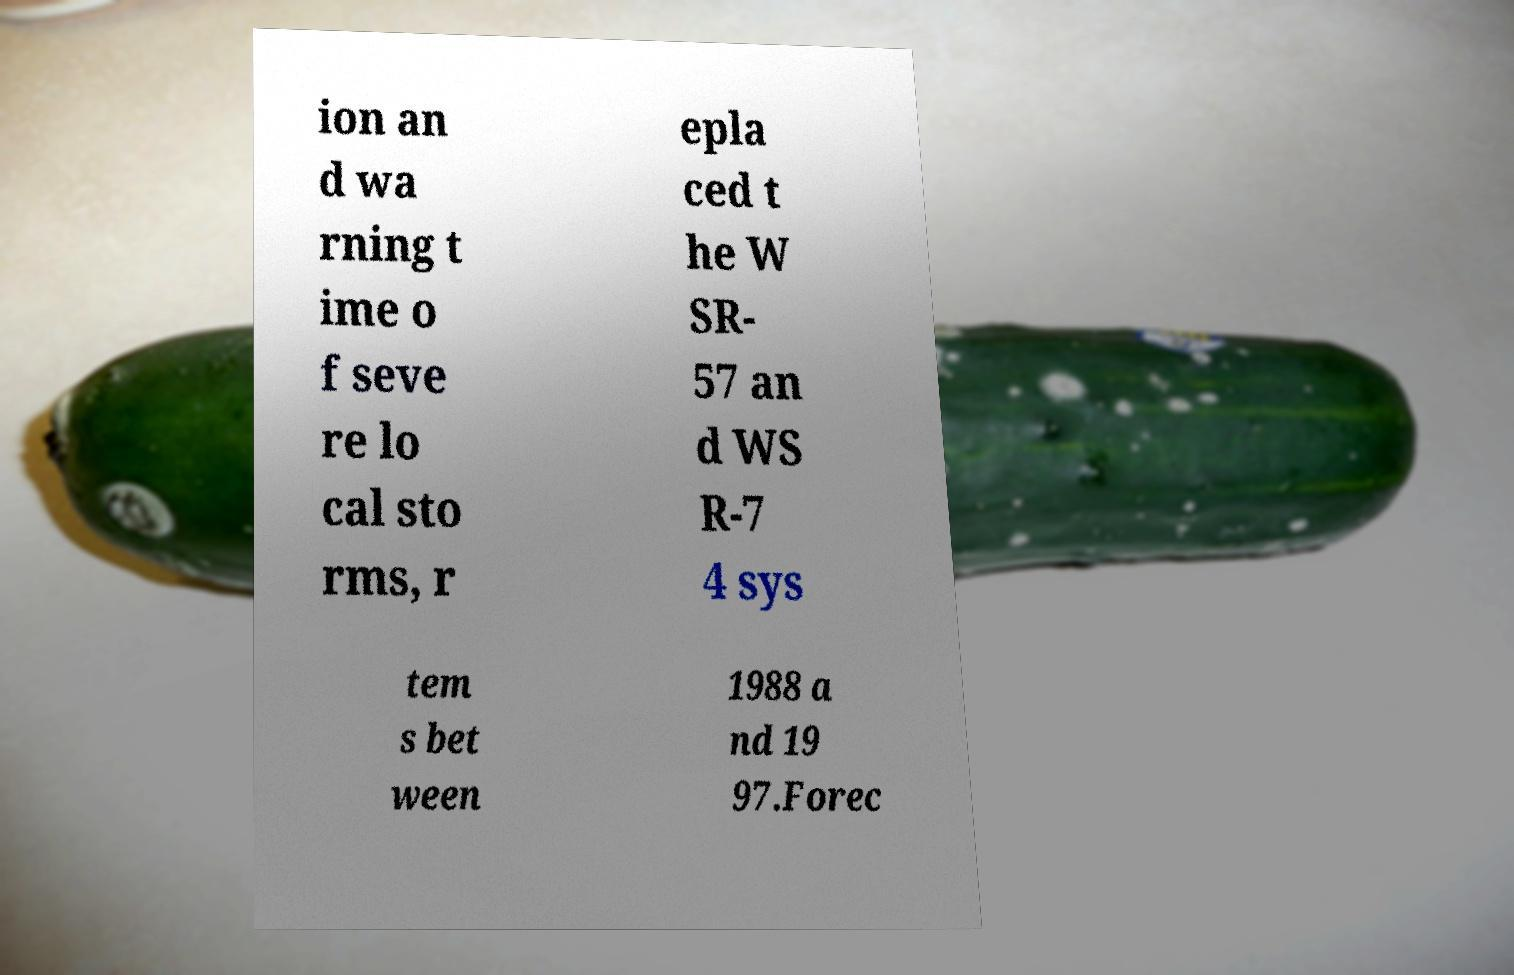Could you assist in decoding the text presented in this image and type it out clearly? ion an d wa rning t ime o f seve re lo cal sto rms, r epla ced t he W SR- 57 an d WS R-7 4 sys tem s bet ween 1988 a nd 19 97.Forec 